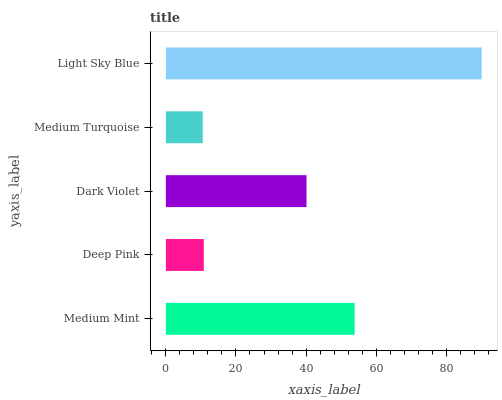Is Medium Turquoise the minimum?
Answer yes or no. Yes. Is Light Sky Blue the maximum?
Answer yes or no. Yes. Is Deep Pink the minimum?
Answer yes or no. No. Is Deep Pink the maximum?
Answer yes or no. No. Is Medium Mint greater than Deep Pink?
Answer yes or no. Yes. Is Deep Pink less than Medium Mint?
Answer yes or no. Yes. Is Deep Pink greater than Medium Mint?
Answer yes or no. No. Is Medium Mint less than Deep Pink?
Answer yes or no. No. Is Dark Violet the high median?
Answer yes or no. Yes. Is Dark Violet the low median?
Answer yes or no. Yes. Is Deep Pink the high median?
Answer yes or no. No. Is Medium Turquoise the low median?
Answer yes or no. No. 